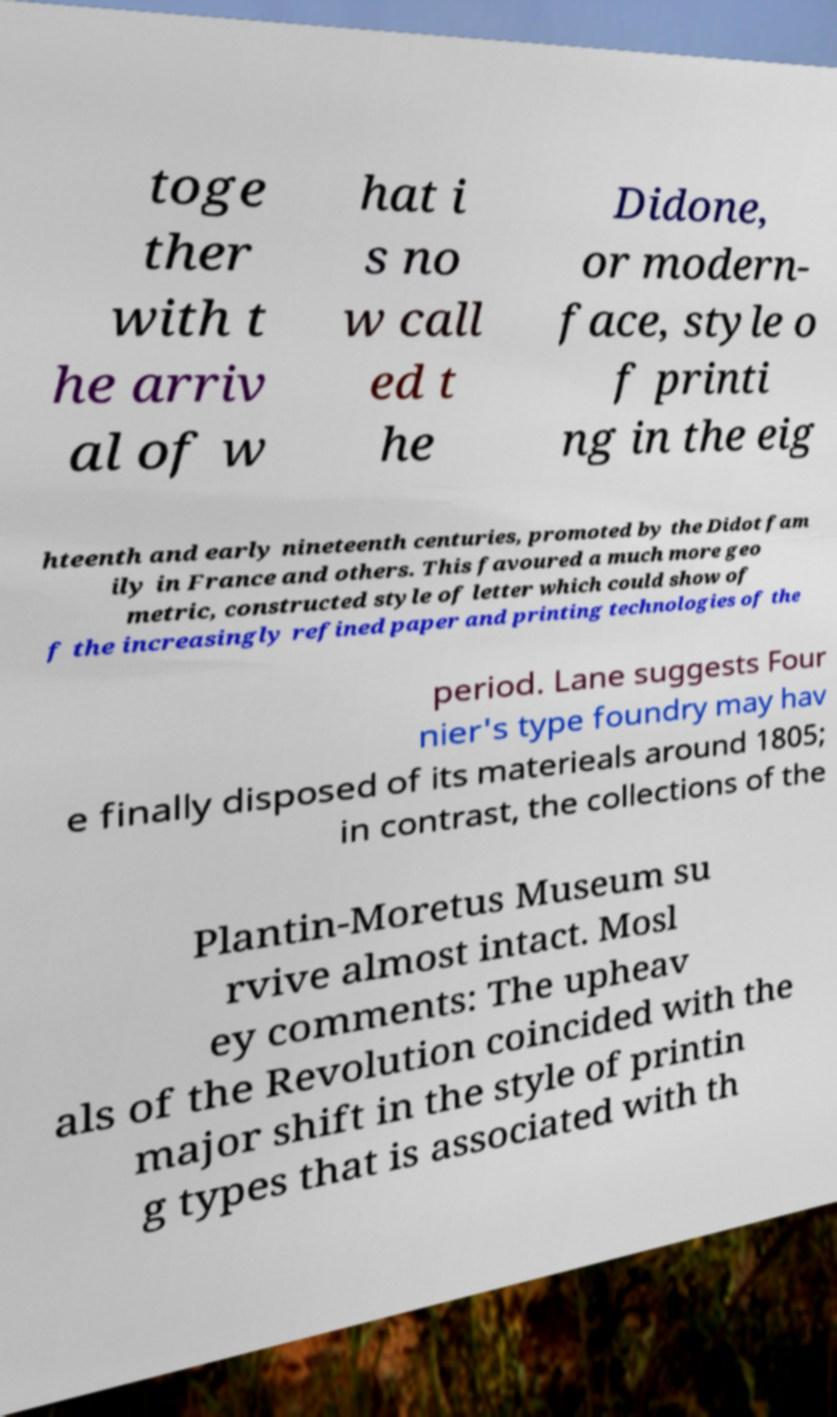What messages or text are displayed in this image? I need them in a readable, typed format. toge ther with t he arriv al of w hat i s no w call ed t he Didone, or modern- face, style o f printi ng in the eig hteenth and early nineteenth centuries, promoted by the Didot fam ily in France and others. This favoured a much more geo metric, constructed style of letter which could show of f the increasingly refined paper and printing technologies of the period. Lane suggests Four nier's type foundry may hav e finally disposed of its materieals around 1805; in contrast, the collections of the Plantin-Moretus Museum su rvive almost intact. Mosl ey comments: The upheav als of the Revolution coincided with the major shift in the style of printin g types that is associated with th 